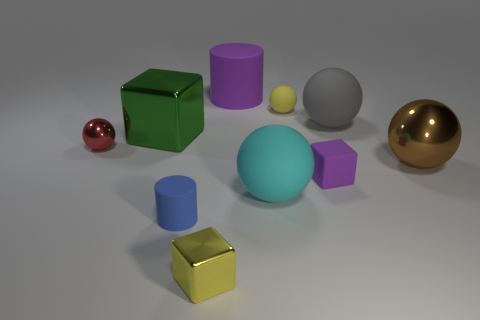What is the color of the cube that is both in front of the green cube and on the left side of the cyan object?
Make the answer very short. Yellow. There is a red thing that is the same material as the green cube; what shape is it?
Your answer should be very brief. Sphere. How many big things are both on the left side of the tiny blue thing and on the right side of the small rubber block?
Keep it short and to the point. 0. Are there any tiny yellow things in front of the blue matte thing?
Your response must be concise. Yes. Do the small metal thing that is to the right of the blue thing and the large thing that is behind the gray matte ball have the same shape?
Keep it short and to the point. No. What number of objects are either large brown shiny balls or shiny things to the right of the yellow block?
Keep it short and to the point. 1. How many other things are there of the same shape as the large cyan object?
Ensure brevity in your answer.  4. Does the small cube behind the tiny metal block have the same material as the brown sphere?
Make the answer very short. No. What number of things are tiny cubes or cylinders?
Keep it short and to the point. 4. There is another matte object that is the same shape as the tiny blue rubber thing; what is its size?
Make the answer very short. Large. 